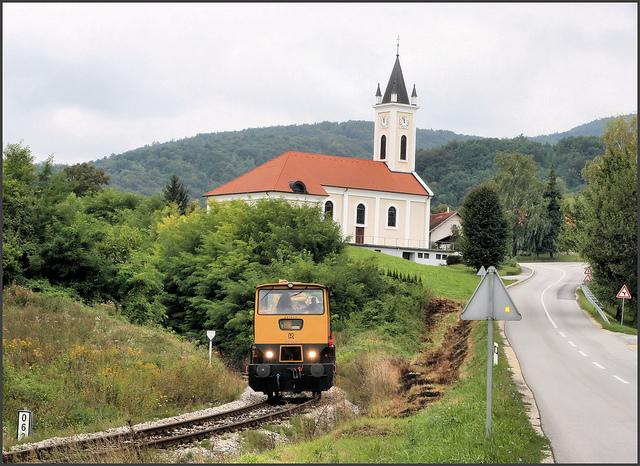What period of the day is shown here? noon 